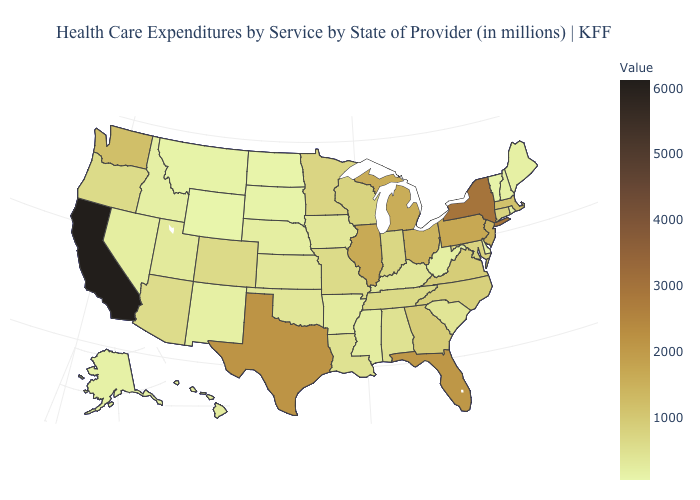Is the legend a continuous bar?
Be succinct. Yes. Which states hav the highest value in the South?
Write a very short answer. Texas. Does Wyoming have the lowest value in the West?
Short answer required. Yes. Does South Carolina have the lowest value in the South?
Keep it brief. No. Does Alabama have the highest value in the South?
Concise answer only. No. 